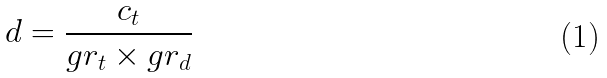Convert formula to latex. <formula><loc_0><loc_0><loc_500><loc_500>d = \frac { c _ { t } } { g r _ { t } \times g r _ { d } }</formula> 